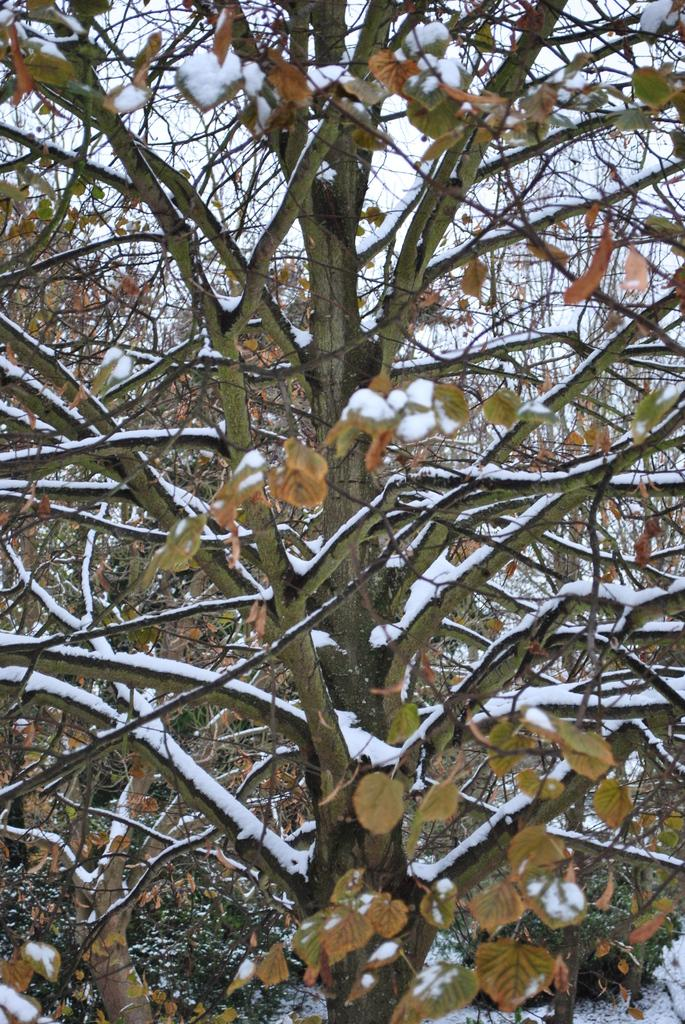What is present in the image? There is a tree in the image. What is the condition of the tree? The tree has snow on it. What type of border can be seen around the tree in the image? There is no border present around the tree in the image. What scent is associated with the tree in the image? The image does not provide any information about the scent of the tree. 